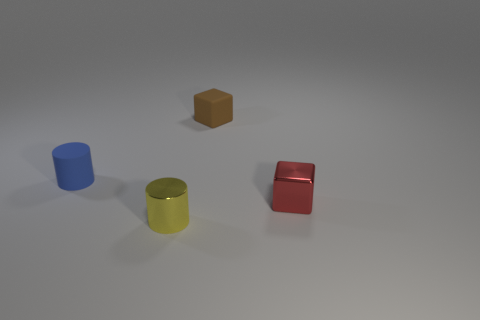Add 2 large blue shiny things. How many objects exist? 6 Add 2 tiny blue cylinders. How many tiny blue cylinders exist? 3 Subtract 0 green cylinders. How many objects are left? 4 Subtract all tiny red cubes. Subtract all brown matte cubes. How many objects are left? 2 Add 1 small cylinders. How many small cylinders are left? 3 